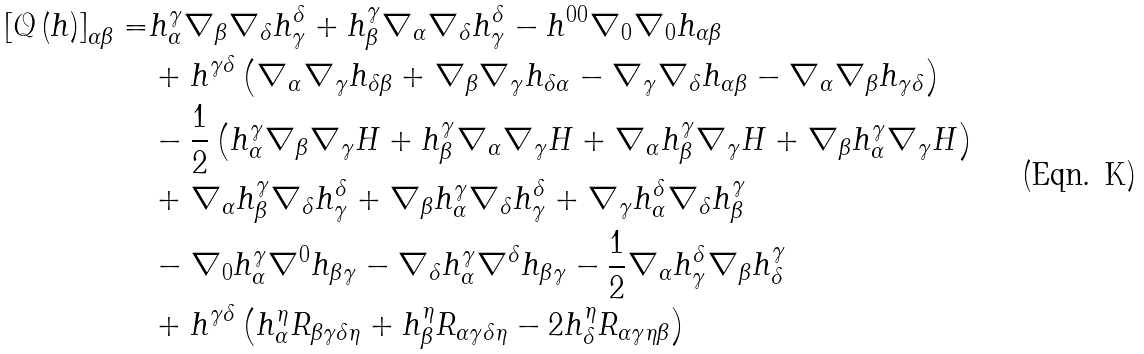Convert formula to latex. <formula><loc_0><loc_0><loc_500><loc_500>\left [ \mathcal { Q } \left ( h \right ) \right ] _ { \alpha \beta } = & h _ { \alpha } ^ { \gamma } \nabla _ { \beta } \nabla _ { \delta } h _ { \gamma } ^ { \delta } + h _ { \beta } ^ { \gamma } \nabla _ { \alpha } \nabla _ { \delta } h _ { \gamma } ^ { \delta } - h ^ { 0 0 } \nabla _ { 0 } \nabla _ { 0 } h _ { \alpha \beta } \\ & + h ^ { \gamma \delta } \left ( \nabla _ { \alpha } \nabla _ { \gamma } h _ { \delta \beta } + \nabla _ { \beta } \nabla _ { \gamma } h _ { \delta \alpha } - \nabla _ { \gamma } \nabla _ { \delta } h _ { \alpha \beta } - \nabla _ { \alpha } \nabla _ { \beta } h _ { \gamma \delta } \right ) \\ & - \frac { 1 } { 2 } \left ( h _ { \alpha } ^ { \gamma } \nabla _ { \beta } \nabla _ { \gamma } H + h _ { \beta } ^ { \gamma } \nabla _ { \alpha } \nabla _ { \gamma } H + \nabla _ { \alpha } h _ { \beta } ^ { \gamma } \nabla _ { \gamma } H + \nabla _ { \beta } h _ { \alpha } ^ { \gamma } \nabla _ { \gamma } H \right ) \\ & + \nabla _ { \alpha } h _ { \beta } ^ { \gamma } \nabla _ { \delta } h _ { \gamma } ^ { \delta } + \nabla _ { \beta } h _ { \alpha } ^ { \gamma } \nabla _ { \delta } h _ { \gamma } ^ { \delta } + \nabla _ { \gamma } h _ { \alpha } ^ { \delta } \nabla _ { \delta } h _ { \beta } ^ { \gamma } \\ & - \nabla _ { 0 } h _ { \alpha } ^ { \gamma } \nabla ^ { 0 } h _ { \beta \gamma } - \nabla _ { \delta } h _ { \alpha } ^ { \gamma } \nabla ^ { \delta } h _ { \beta \gamma } - \frac { 1 } { 2 } \nabla _ { \alpha } h _ { \gamma } ^ { \delta } \nabla _ { \beta } h _ { \delta } ^ { \gamma } \\ & + h ^ { \gamma \delta } \left ( h _ { \alpha } ^ { \eta } R _ { \beta \gamma \delta \eta } + h _ { \beta } ^ { \eta } R _ { \alpha \gamma \delta \eta } - 2 h _ { \delta } ^ { \eta } R _ { \alpha \gamma \eta \beta } \right )</formula> 